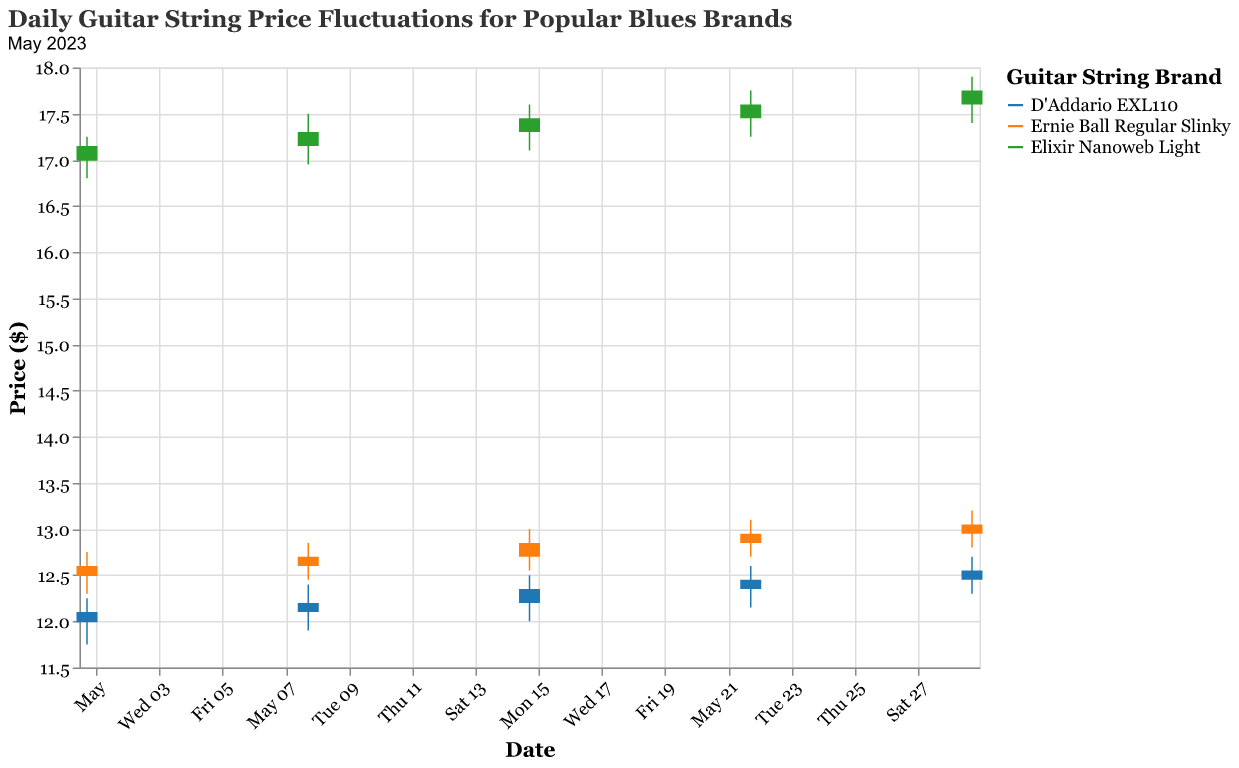What is the highest price reached by the Elixir Nanoweb Light strings in May 2023? The highest price for Elixir Nanoweb Light can be seen by looking for the maximum 'High' value in the data for May 2023. According to the values, it is $17.90.
Answer: 17.90 Which brand had the highest closing price on May 1, 2023? By examining the 'Close' prices for each brand on May 1, 2023, we see that Elixir Nanoweb Light had the highest closing price of $17.15.
Answer: Elixir Nanoweb Light Between which dates did the D'Addario EXL110 strings exhibit the largest increase in closing price? The largest increase can be determined by comparing the closing prices across different dates: 
From May 1 to May 8: 12.10 to 12.20 (+0.10)
From May 8 to May 15: 12.20 to 12.35 (+0.15)
From May 15 to May 22: 12.35 to 12.45 (+0.10)
From May 22 to May 29: 12.45 to 12.55 (+0.10)
The largest increase is between May 8 and May 15.
Answer: May 8 to May 15 On which date did the Ernie Ball Regular Slinky strings have the smallest range between the high and low prices? The range between the high and low prices can be calculated for each date for Ernie Ball Regular Slinky:
May 1: 12.75 - 12.30 = 0.45
May 8: 12.85 - 12.45 = 0.40
May 15: 13.00 - 12.55 = 0.45
May 22: 13.10 - 12.70 = 0.40
May 29: 13.20 - 12.80 = 0.40
The smallest range is $0.40 on May 8, May 22, and May 29.
Answer: May 8, May 22, May 29 How did the closing price for Ernie Ball Regular Slinky strings change over the month? By looking at the 'Close' prices for Ernie Ball Regular Slinky throughout May: 
May 1: 12.60
May 8: 12.70 (+0.10)
May 15: 12.85 (+0.15)
May 22: 12.95 (+0.10)
May 29: 13.05 (+0.10)
The closing price increased incrementally every week.
Answer: Increased incrementally Which brand had the smallest absolute change in closing price from the beginning to the end of May? The change in closing price for each brand from May 1 to May 29 can be calculated:
D'Addario EXL110: 12.55 - 12.10 = 0.45
Ernie Ball Regular Slinky: 13.05 - 12.60 = 0.45
Elixir Nanoweb Light: 17.75 - 17.15 = 0.60
D'Addario EXL110 and Ernie Ball Regular Slinky both have the smallest change of 0.45.
Answer: D'Addario EXL110, Ernie Ball Regular Slinky What was the average closing price of the Elixir Nanoweb Light strings during May 2023? The average closing price can be calculated by summing the 'Close' prices for Elixir Nanoweb Light and then dividing by the number of dates (5). 
(17.15 + 17.30 + 17.45 + 17.60 + 17.75) / 5 = 87.25 / 5 = 17.45
Answer: 17.45 